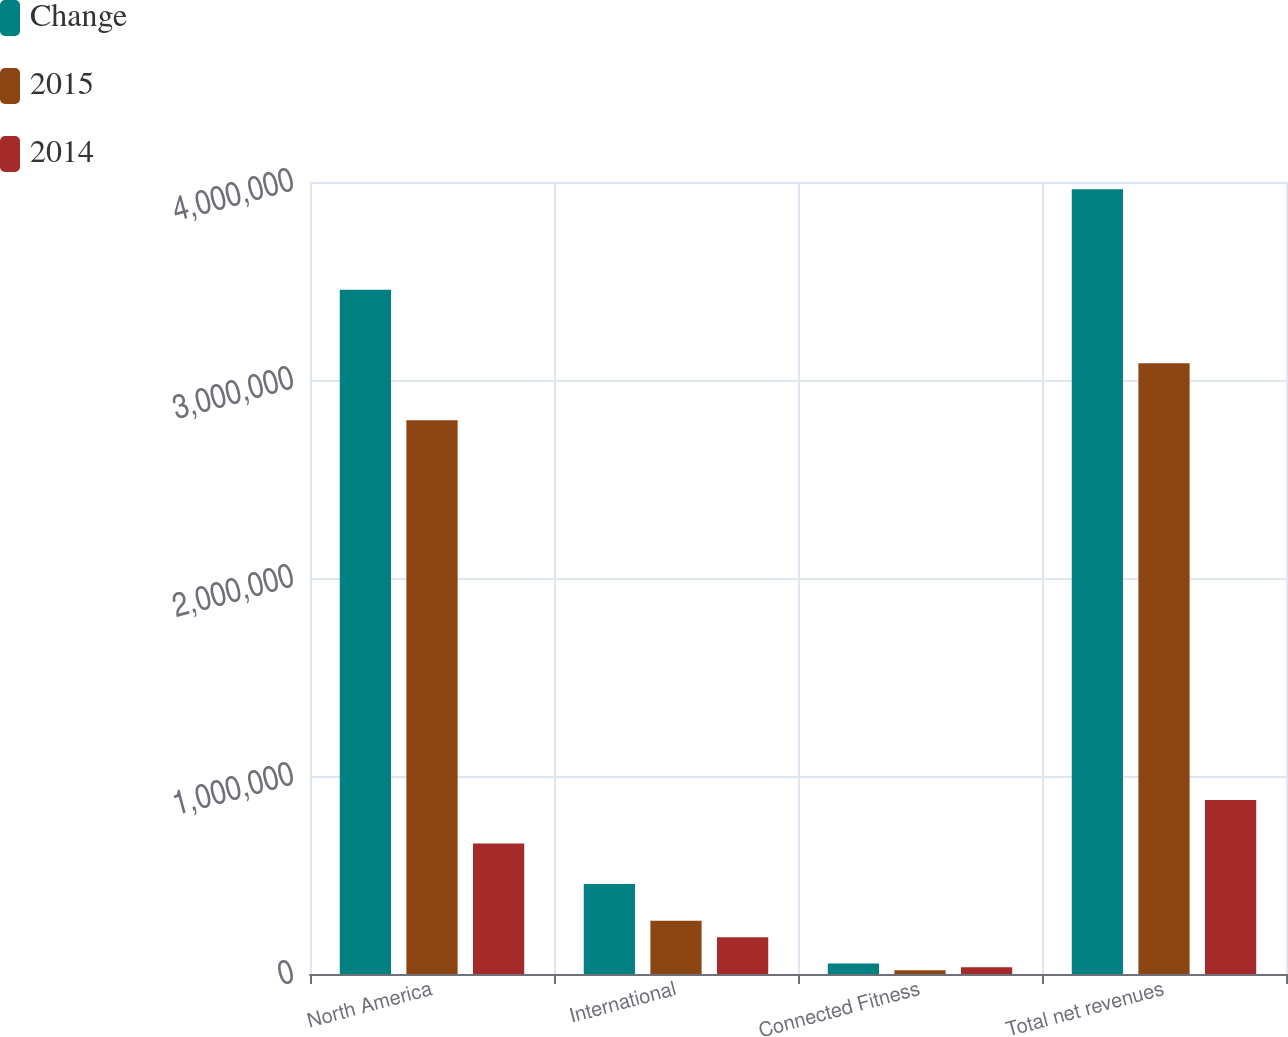<chart> <loc_0><loc_0><loc_500><loc_500><stacked_bar_chart><ecel><fcel>North America<fcel>International<fcel>Connected Fitness<fcel>Total net revenues<nl><fcel>Change<fcel>3.45574e+06<fcel>454161<fcel>53415<fcel>3.96331e+06<nl><fcel>2015<fcel>2.79637e+06<fcel>268771<fcel>19225<fcel>3.08437e+06<nl><fcel>2014<fcel>659363<fcel>185390<fcel>34190<fcel>878943<nl></chart> 